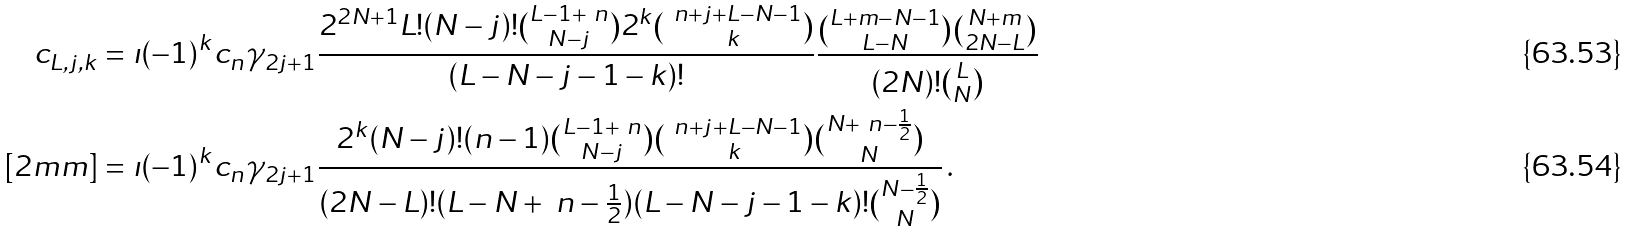<formula> <loc_0><loc_0><loc_500><loc_500>c _ { L , j , k } & = \imath ( - 1 ) ^ { k } c _ { n } \gamma _ { 2 j + 1 } \frac { 2 ^ { 2 N + 1 } L ! ( N - j ) ! { L - 1 + \ n \choose N - j } 2 ^ { k } { \ n + j + L - N - 1 \choose k } } { ( L - N - j - 1 - k ) ! } \frac { { L + m - N - 1 \choose L - N } { N + m \choose 2 N - L } } { ( 2 N ) ! { L \choose N } } \\ [ 2 m m ] & = \imath ( - 1 ) ^ { k } c _ { n } \gamma _ { 2 j + 1 } \frac { 2 ^ { k } ( N - j ) ! ( n - 1 ) { L - 1 + \ n \choose N - j } { \ n + j + L - N - 1 \choose k } { N + \ n - \frac { 1 } { 2 } \choose N } } { ( 2 N - L ) ! ( L - N + \ n - \frac { 1 } { 2 } ) ( L - N - j - 1 - k ) ! { N - \frac { 1 } { 2 } \choose N } } \, .</formula> 